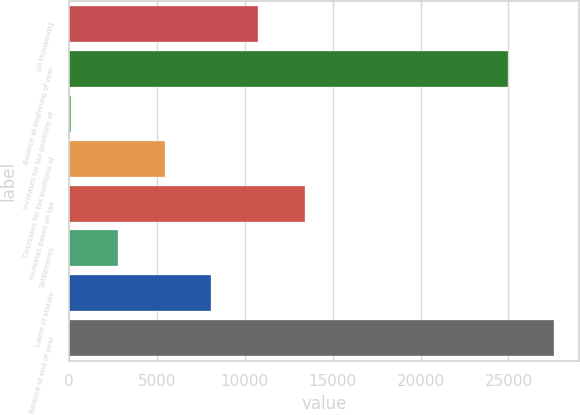Convert chart. <chart><loc_0><loc_0><loc_500><loc_500><bar_chart><fcel>(In thousands)<fcel>Balance at beginning of year<fcel>Increases for tax positions of<fcel>Decreases for tax positions of<fcel>Increases based on tax<fcel>Settlements<fcel>Lapse of statute<fcel>Balance at end of year<nl><fcel>10783.4<fcel>24951<fcel>125<fcel>5454.2<fcel>13448<fcel>2789.6<fcel>8118.8<fcel>27615.6<nl></chart> 